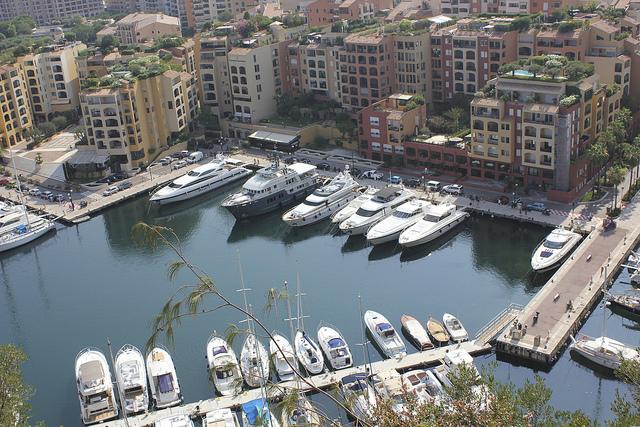How many boats do you see?
Give a very brief answer. 30. What is on top of the building next to the last yacht?
Keep it brief. Trees. Is this marina manmade?
Quick response, please. Yes. 